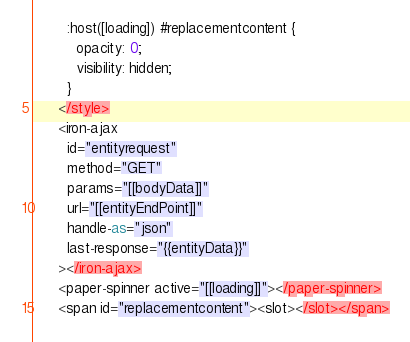<code> <loc_0><loc_0><loc_500><loc_500><_JavaScript_>        :host([loading]) #replacementcontent {
          opacity: 0;
          visibility: hidden;
        }
      </style>
      <iron-ajax
        id="entityrequest"
        method="GET"
        params="[[bodyData]]"
        url="[[entityEndPoint]]"
        handle-as="json"
        last-response="{{entityData}}"
      ></iron-ajax>
      <paper-spinner active="[[loading]]"></paper-spinner>
      <span id="replacementcontent"><slot></slot></span></code> 